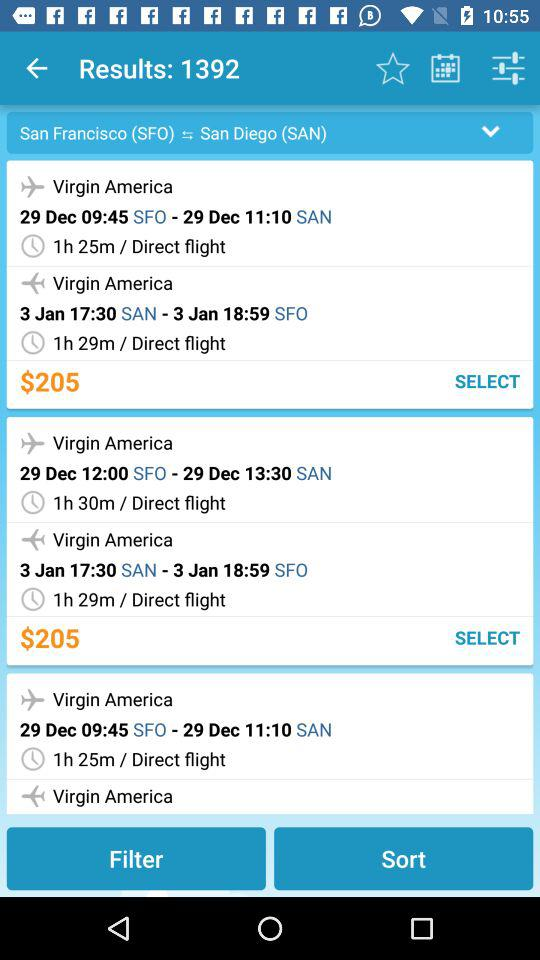What is the departure time of the flight from SAN to SFO? The departure time of the flight from SAN to SFO is 17:30. 